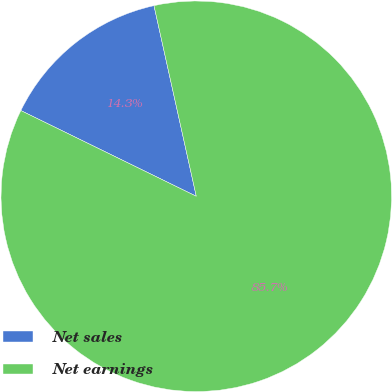Convert chart to OTSL. <chart><loc_0><loc_0><loc_500><loc_500><pie_chart><fcel>Net sales<fcel>Net earnings<nl><fcel>14.29%<fcel>85.71%<nl></chart> 